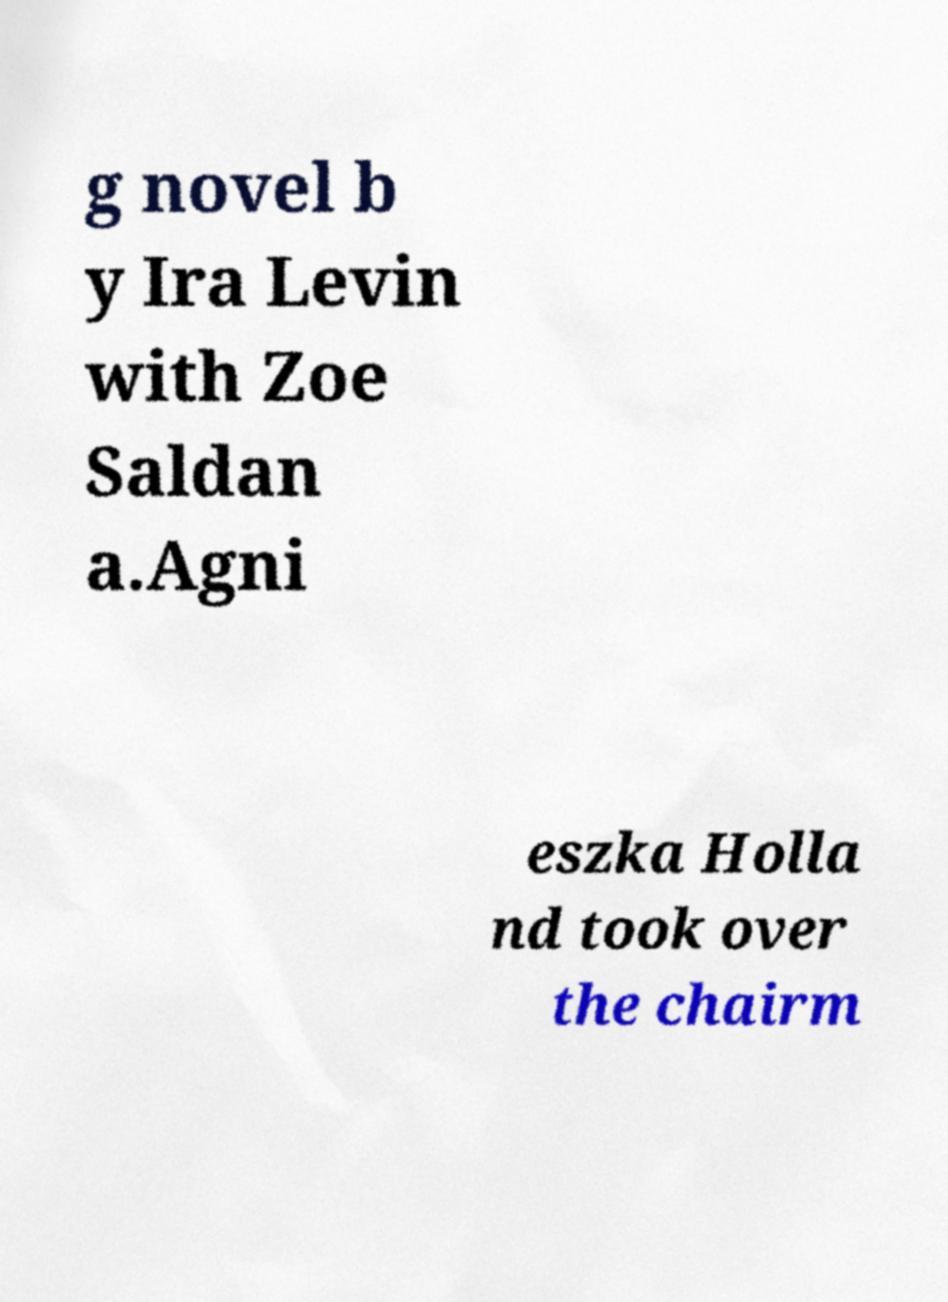I need the written content from this picture converted into text. Can you do that? g novel b y Ira Levin with Zoe Saldan a.Agni eszka Holla nd took over the chairm 